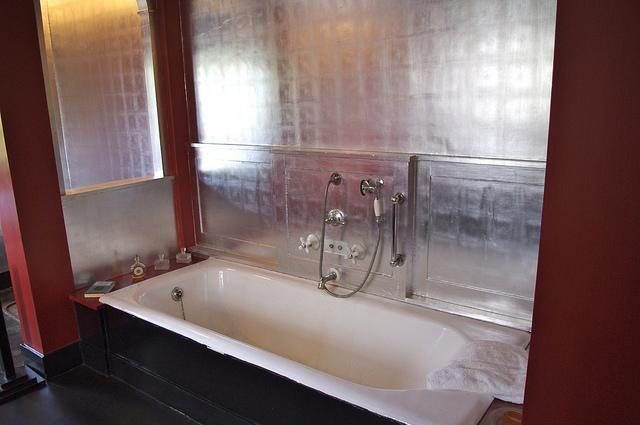What room is this?
Answer briefly. Bathroom. What color is the tub?
Short answer required. White. What is the length of the shower head tube extension?
Quick response, please. Silver. 